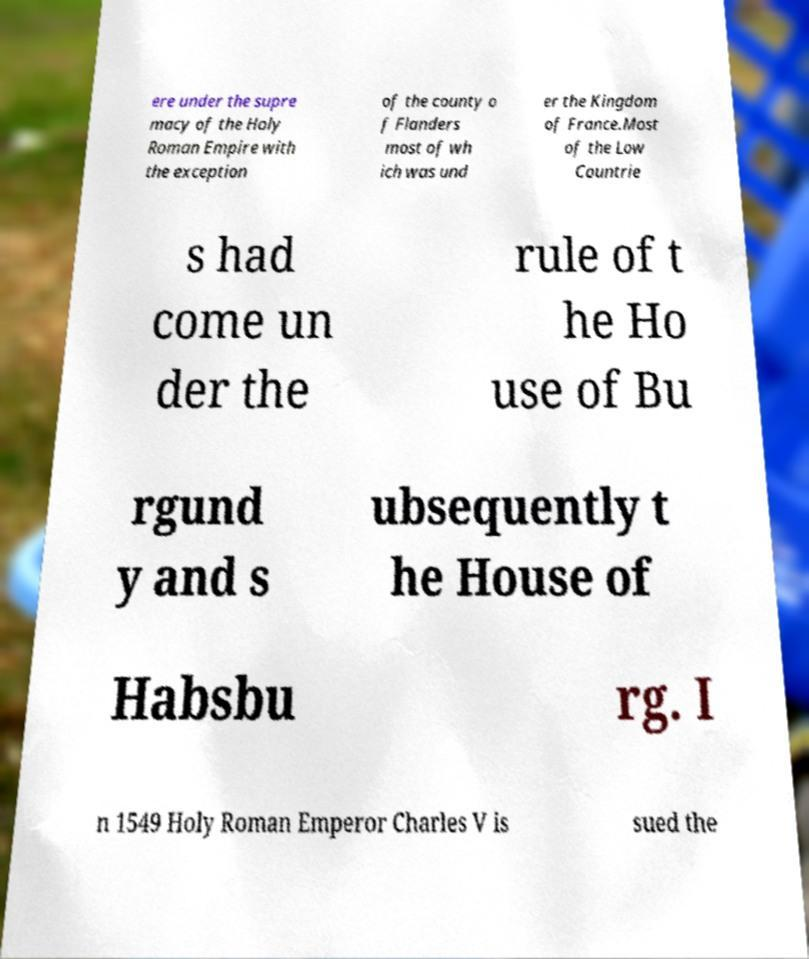Please read and relay the text visible in this image. What does it say? ere under the supre macy of the Holy Roman Empire with the exception of the county o f Flanders most of wh ich was und er the Kingdom of France.Most of the Low Countrie s had come un der the rule of t he Ho use of Bu rgund y and s ubsequently t he House of Habsbu rg. I n 1549 Holy Roman Emperor Charles V is sued the 